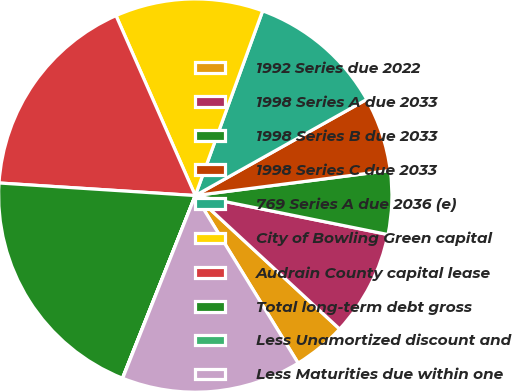Convert chart. <chart><loc_0><loc_0><loc_500><loc_500><pie_chart><fcel>1992 Series due 2022<fcel>1998 Series A due 2033<fcel>1998 Series B due 2033<fcel>1998 Series C due 2033<fcel>769 Series A due 2036 (e)<fcel>City of Bowling Green capital<fcel>Audrain County capital lease<fcel>Total long-term debt gross<fcel>Less Unamortized discount and<fcel>Less Maturities due within one<nl><fcel>4.36%<fcel>8.7%<fcel>5.22%<fcel>6.09%<fcel>11.3%<fcel>12.17%<fcel>17.38%<fcel>19.98%<fcel>0.02%<fcel>14.78%<nl></chart> 